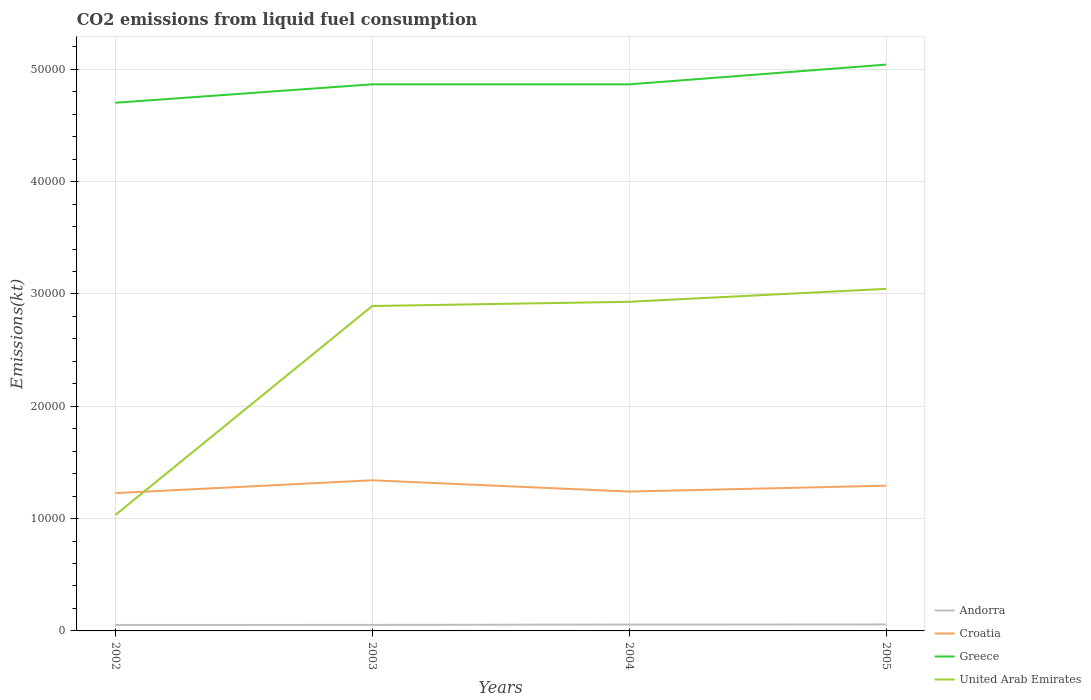Is the number of lines equal to the number of legend labels?
Keep it short and to the point. Yes. Across all years, what is the maximum amount of CO2 emitted in Croatia?
Ensure brevity in your answer.  1.23e+04. In which year was the amount of CO2 emitted in Greece maximum?
Your answer should be compact. 2002. What is the total amount of CO2 emitted in Greece in the graph?
Offer a very short reply. 3.67. What is the difference between the highest and the second highest amount of CO2 emitted in Andorra?
Your answer should be compact. 44. What is the difference between the highest and the lowest amount of CO2 emitted in Andorra?
Your response must be concise. 2. How many years are there in the graph?
Offer a terse response. 4. Does the graph contain any zero values?
Offer a very short reply. No. Where does the legend appear in the graph?
Your response must be concise. Bottom right. How many legend labels are there?
Provide a succinct answer. 4. What is the title of the graph?
Offer a terse response. CO2 emissions from liquid fuel consumption. What is the label or title of the Y-axis?
Give a very brief answer. Emissions(kt). What is the Emissions(kt) in Andorra in 2002?
Your response must be concise. 531.72. What is the Emissions(kt) in Croatia in 2002?
Your response must be concise. 1.23e+04. What is the Emissions(kt) of Greece in 2002?
Provide a succinct answer. 4.70e+04. What is the Emissions(kt) in United Arab Emirates in 2002?
Make the answer very short. 1.03e+04. What is the Emissions(kt) of Andorra in 2003?
Give a very brief answer. 535.38. What is the Emissions(kt) in Croatia in 2003?
Provide a short and direct response. 1.34e+04. What is the Emissions(kt) of Greece in 2003?
Your response must be concise. 4.87e+04. What is the Emissions(kt) of United Arab Emirates in 2003?
Give a very brief answer. 2.89e+04. What is the Emissions(kt) in Andorra in 2004?
Give a very brief answer. 564.72. What is the Emissions(kt) in Croatia in 2004?
Ensure brevity in your answer.  1.24e+04. What is the Emissions(kt) of Greece in 2004?
Offer a very short reply. 4.87e+04. What is the Emissions(kt) of United Arab Emirates in 2004?
Keep it short and to the point. 2.93e+04. What is the Emissions(kt) in Andorra in 2005?
Give a very brief answer. 575.72. What is the Emissions(kt) of Croatia in 2005?
Your answer should be very brief. 1.29e+04. What is the Emissions(kt) of Greece in 2005?
Keep it short and to the point. 5.04e+04. What is the Emissions(kt) of United Arab Emirates in 2005?
Keep it short and to the point. 3.05e+04. Across all years, what is the maximum Emissions(kt) of Andorra?
Give a very brief answer. 575.72. Across all years, what is the maximum Emissions(kt) in Croatia?
Make the answer very short. 1.34e+04. Across all years, what is the maximum Emissions(kt) in Greece?
Your response must be concise. 5.04e+04. Across all years, what is the maximum Emissions(kt) of United Arab Emirates?
Offer a very short reply. 3.05e+04. Across all years, what is the minimum Emissions(kt) in Andorra?
Make the answer very short. 531.72. Across all years, what is the minimum Emissions(kt) of Croatia?
Keep it short and to the point. 1.23e+04. Across all years, what is the minimum Emissions(kt) of Greece?
Give a very brief answer. 4.70e+04. Across all years, what is the minimum Emissions(kt) in United Arab Emirates?
Ensure brevity in your answer.  1.03e+04. What is the total Emissions(kt) in Andorra in the graph?
Make the answer very short. 2207.53. What is the total Emissions(kt) in Croatia in the graph?
Your answer should be compact. 5.10e+04. What is the total Emissions(kt) of Greece in the graph?
Offer a very short reply. 1.95e+05. What is the total Emissions(kt) in United Arab Emirates in the graph?
Offer a terse response. 9.90e+04. What is the difference between the Emissions(kt) of Andorra in 2002 and that in 2003?
Offer a terse response. -3.67. What is the difference between the Emissions(kt) of Croatia in 2002 and that in 2003?
Your answer should be compact. -1140.44. What is the difference between the Emissions(kt) of Greece in 2002 and that in 2003?
Keep it short and to the point. -1642.82. What is the difference between the Emissions(kt) in United Arab Emirates in 2002 and that in 2003?
Give a very brief answer. -1.86e+04. What is the difference between the Emissions(kt) in Andorra in 2002 and that in 2004?
Keep it short and to the point. -33. What is the difference between the Emissions(kt) of Croatia in 2002 and that in 2004?
Your answer should be very brief. -139.35. What is the difference between the Emissions(kt) in Greece in 2002 and that in 2004?
Your response must be concise. -1639.15. What is the difference between the Emissions(kt) of United Arab Emirates in 2002 and that in 2004?
Your response must be concise. -1.90e+04. What is the difference between the Emissions(kt) of Andorra in 2002 and that in 2005?
Make the answer very short. -44. What is the difference between the Emissions(kt) in Croatia in 2002 and that in 2005?
Ensure brevity in your answer.  -660.06. What is the difference between the Emissions(kt) in Greece in 2002 and that in 2005?
Provide a short and direct response. -3399.31. What is the difference between the Emissions(kt) of United Arab Emirates in 2002 and that in 2005?
Provide a succinct answer. -2.01e+04. What is the difference between the Emissions(kt) of Andorra in 2003 and that in 2004?
Keep it short and to the point. -29.34. What is the difference between the Emissions(kt) in Croatia in 2003 and that in 2004?
Make the answer very short. 1001.09. What is the difference between the Emissions(kt) of Greece in 2003 and that in 2004?
Your answer should be compact. 3.67. What is the difference between the Emissions(kt) in United Arab Emirates in 2003 and that in 2004?
Ensure brevity in your answer.  -374.03. What is the difference between the Emissions(kt) of Andorra in 2003 and that in 2005?
Offer a terse response. -40.34. What is the difference between the Emissions(kt) of Croatia in 2003 and that in 2005?
Your response must be concise. 480.38. What is the difference between the Emissions(kt) in Greece in 2003 and that in 2005?
Provide a succinct answer. -1756.49. What is the difference between the Emissions(kt) in United Arab Emirates in 2003 and that in 2005?
Offer a terse response. -1525.47. What is the difference between the Emissions(kt) in Andorra in 2004 and that in 2005?
Your answer should be compact. -11. What is the difference between the Emissions(kt) of Croatia in 2004 and that in 2005?
Offer a very short reply. -520.71. What is the difference between the Emissions(kt) in Greece in 2004 and that in 2005?
Ensure brevity in your answer.  -1760.16. What is the difference between the Emissions(kt) of United Arab Emirates in 2004 and that in 2005?
Keep it short and to the point. -1151.44. What is the difference between the Emissions(kt) of Andorra in 2002 and the Emissions(kt) of Croatia in 2003?
Give a very brief answer. -1.29e+04. What is the difference between the Emissions(kt) of Andorra in 2002 and the Emissions(kt) of Greece in 2003?
Provide a succinct answer. -4.81e+04. What is the difference between the Emissions(kt) in Andorra in 2002 and the Emissions(kt) in United Arab Emirates in 2003?
Your answer should be compact. -2.84e+04. What is the difference between the Emissions(kt) of Croatia in 2002 and the Emissions(kt) of Greece in 2003?
Make the answer very short. -3.64e+04. What is the difference between the Emissions(kt) of Croatia in 2002 and the Emissions(kt) of United Arab Emirates in 2003?
Offer a very short reply. -1.67e+04. What is the difference between the Emissions(kt) of Greece in 2002 and the Emissions(kt) of United Arab Emirates in 2003?
Make the answer very short. 1.81e+04. What is the difference between the Emissions(kt) of Andorra in 2002 and the Emissions(kt) of Croatia in 2004?
Provide a short and direct response. -1.19e+04. What is the difference between the Emissions(kt) of Andorra in 2002 and the Emissions(kt) of Greece in 2004?
Provide a short and direct response. -4.81e+04. What is the difference between the Emissions(kt) in Andorra in 2002 and the Emissions(kt) in United Arab Emirates in 2004?
Your answer should be compact. -2.88e+04. What is the difference between the Emissions(kt) in Croatia in 2002 and the Emissions(kt) in Greece in 2004?
Make the answer very short. -3.64e+04. What is the difference between the Emissions(kt) of Croatia in 2002 and the Emissions(kt) of United Arab Emirates in 2004?
Offer a terse response. -1.70e+04. What is the difference between the Emissions(kt) in Greece in 2002 and the Emissions(kt) in United Arab Emirates in 2004?
Keep it short and to the point. 1.77e+04. What is the difference between the Emissions(kt) of Andorra in 2002 and the Emissions(kt) of Croatia in 2005?
Make the answer very short. -1.24e+04. What is the difference between the Emissions(kt) of Andorra in 2002 and the Emissions(kt) of Greece in 2005?
Provide a succinct answer. -4.99e+04. What is the difference between the Emissions(kt) in Andorra in 2002 and the Emissions(kt) in United Arab Emirates in 2005?
Make the answer very short. -2.99e+04. What is the difference between the Emissions(kt) in Croatia in 2002 and the Emissions(kt) in Greece in 2005?
Your answer should be very brief. -3.82e+04. What is the difference between the Emissions(kt) of Croatia in 2002 and the Emissions(kt) of United Arab Emirates in 2005?
Offer a very short reply. -1.82e+04. What is the difference between the Emissions(kt) of Greece in 2002 and the Emissions(kt) of United Arab Emirates in 2005?
Give a very brief answer. 1.66e+04. What is the difference between the Emissions(kt) in Andorra in 2003 and the Emissions(kt) in Croatia in 2004?
Offer a terse response. -1.19e+04. What is the difference between the Emissions(kt) in Andorra in 2003 and the Emissions(kt) in Greece in 2004?
Provide a succinct answer. -4.81e+04. What is the difference between the Emissions(kt) of Andorra in 2003 and the Emissions(kt) of United Arab Emirates in 2004?
Your answer should be very brief. -2.88e+04. What is the difference between the Emissions(kt) of Croatia in 2003 and the Emissions(kt) of Greece in 2004?
Offer a terse response. -3.53e+04. What is the difference between the Emissions(kt) in Croatia in 2003 and the Emissions(kt) in United Arab Emirates in 2004?
Make the answer very short. -1.59e+04. What is the difference between the Emissions(kt) of Greece in 2003 and the Emissions(kt) of United Arab Emirates in 2004?
Offer a very short reply. 1.94e+04. What is the difference between the Emissions(kt) of Andorra in 2003 and the Emissions(kt) of Croatia in 2005?
Keep it short and to the point. -1.24e+04. What is the difference between the Emissions(kt) of Andorra in 2003 and the Emissions(kt) of Greece in 2005?
Keep it short and to the point. -4.99e+04. What is the difference between the Emissions(kt) in Andorra in 2003 and the Emissions(kt) in United Arab Emirates in 2005?
Your response must be concise. -2.99e+04. What is the difference between the Emissions(kt) of Croatia in 2003 and the Emissions(kt) of Greece in 2005?
Your answer should be compact. -3.70e+04. What is the difference between the Emissions(kt) of Croatia in 2003 and the Emissions(kt) of United Arab Emirates in 2005?
Your response must be concise. -1.70e+04. What is the difference between the Emissions(kt) of Greece in 2003 and the Emissions(kt) of United Arab Emirates in 2005?
Your response must be concise. 1.82e+04. What is the difference between the Emissions(kt) in Andorra in 2004 and the Emissions(kt) in Croatia in 2005?
Provide a succinct answer. -1.24e+04. What is the difference between the Emissions(kt) in Andorra in 2004 and the Emissions(kt) in Greece in 2005?
Offer a very short reply. -4.99e+04. What is the difference between the Emissions(kt) of Andorra in 2004 and the Emissions(kt) of United Arab Emirates in 2005?
Provide a succinct answer. -2.99e+04. What is the difference between the Emissions(kt) in Croatia in 2004 and the Emissions(kt) in Greece in 2005?
Offer a terse response. -3.80e+04. What is the difference between the Emissions(kt) in Croatia in 2004 and the Emissions(kt) in United Arab Emirates in 2005?
Make the answer very short. -1.80e+04. What is the difference between the Emissions(kt) in Greece in 2004 and the Emissions(kt) in United Arab Emirates in 2005?
Keep it short and to the point. 1.82e+04. What is the average Emissions(kt) of Andorra per year?
Provide a succinct answer. 551.88. What is the average Emissions(kt) of Croatia per year?
Ensure brevity in your answer.  1.28e+04. What is the average Emissions(kt) of Greece per year?
Ensure brevity in your answer.  4.87e+04. What is the average Emissions(kt) of United Arab Emirates per year?
Offer a very short reply. 2.48e+04. In the year 2002, what is the difference between the Emissions(kt) of Andorra and Emissions(kt) of Croatia?
Make the answer very short. -1.17e+04. In the year 2002, what is the difference between the Emissions(kt) in Andorra and Emissions(kt) in Greece?
Keep it short and to the point. -4.65e+04. In the year 2002, what is the difference between the Emissions(kt) in Andorra and Emissions(kt) in United Arab Emirates?
Ensure brevity in your answer.  -9787.22. In the year 2002, what is the difference between the Emissions(kt) of Croatia and Emissions(kt) of Greece?
Offer a very short reply. -3.48e+04. In the year 2002, what is the difference between the Emissions(kt) of Croatia and Emissions(kt) of United Arab Emirates?
Offer a very short reply. 1950.84. In the year 2002, what is the difference between the Emissions(kt) in Greece and Emissions(kt) in United Arab Emirates?
Keep it short and to the point. 3.67e+04. In the year 2003, what is the difference between the Emissions(kt) in Andorra and Emissions(kt) in Croatia?
Your answer should be compact. -1.29e+04. In the year 2003, what is the difference between the Emissions(kt) of Andorra and Emissions(kt) of Greece?
Offer a very short reply. -4.81e+04. In the year 2003, what is the difference between the Emissions(kt) in Andorra and Emissions(kt) in United Arab Emirates?
Keep it short and to the point. -2.84e+04. In the year 2003, what is the difference between the Emissions(kt) in Croatia and Emissions(kt) in Greece?
Your answer should be very brief. -3.53e+04. In the year 2003, what is the difference between the Emissions(kt) in Croatia and Emissions(kt) in United Arab Emirates?
Make the answer very short. -1.55e+04. In the year 2003, what is the difference between the Emissions(kt) in Greece and Emissions(kt) in United Arab Emirates?
Give a very brief answer. 1.97e+04. In the year 2004, what is the difference between the Emissions(kt) in Andorra and Emissions(kt) in Croatia?
Your answer should be compact. -1.18e+04. In the year 2004, what is the difference between the Emissions(kt) in Andorra and Emissions(kt) in Greece?
Keep it short and to the point. -4.81e+04. In the year 2004, what is the difference between the Emissions(kt) in Andorra and Emissions(kt) in United Arab Emirates?
Offer a very short reply. -2.87e+04. In the year 2004, what is the difference between the Emissions(kt) in Croatia and Emissions(kt) in Greece?
Your response must be concise. -3.63e+04. In the year 2004, what is the difference between the Emissions(kt) in Croatia and Emissions(kt) in United Arab Emirates?
Offer a terse response. -1.69e+04. In the year 2004, what is the difference between the Emissions(kt) in Greece and Emissions(kt) in United Arab Emirates?
Give a very brief answer. 1.94e+04. In the year 2005, what is the difference between the Emissions(kt) of Andorra and Emissions(kt) of Croatia?
Give a very brief answer. -1.24e+04. In the year 2005, what is the difference between the Emissions(kt) of Andorra and Emissions(kt) of Greece?
Provide a short and direct response. -4.98e+04. In the year 2005, what is the difference between the Emissions(kt) of Andorra and Emissions(kt) of United Arab Emirates?
Your answer should be very brief. -2.99e+04. In the year 2005, what is the difference between the Emissions(kt) of Croatia and Emissions(kt) of Greece?
Provide a succinct answer. -3.75e+04. In the year 2005, what is the difference between the Emissions(kt) of Croatia and Emissions(kt) of United Arab Emirates?
Give a very brief answer. -1.75e+04. In the year 2005, what is the difference between the Emissions(kt) of Greece and Emissions(kt) of United Arab Emirates?
Provide a succinct answer. 2.00e+04. What is the ratio of the Emissions(kt) in Andorra in 2002 to that in 2003?
Ensure brevity in your answer.  0.99. What is the ratio of the Emissions(kt) in Croatia in 2002 to that in 2003?
Your response must be concise. 0.92. What is the ratio of the Emissions(kt) of Greece in 2002 to that in 2003?
Give a very brief answer. 0.97. What is the ratio of the Emissions(kt) in United Arab Emirates in 2002 to that in 2003?
Offer a terse response. 0.36. What is the ratio of the Emissions(kt) in Andorra in 2002 to that in 2004?
Your response must be concise. 0.94. What is the ratio of the Emissions(kt) of Croatia in 2002 to that in 2004?
Make the answer very short. 0.99. What is the ratio of the Emissions(kt) in Greece in 2002 to that in 2004?
Your response must be concise. 0.97. What is the ratio of the Emissions(kt) of United Arab Emirates in 2002 to that in 2004?
Keep it short and to the point. 0.35. What is the ratio of the Emissions(kt) of Andorra in 2002 to that in 2005?
Give a very brief answer. 0.92. What is the ratio of the Emissions(kt) of Croatia in 2002 to that in 2005?
Your answer should be compact. 0.95. What is the ratio of the Emissions(kt) in Greece in 2002 to that in 2005?
Your answer should be compact. 0.93. What is the ratio of the Emissions(kt) of United Arab Emirates in 2002 to that in 2005?
Keep it short and to the point. 0.34. What is the ratio of the Emissions(kt) in Andorra in 2003 to that in 2004?
Offer a very short reply. 0.95. What is the ratio of the Emissions(kt) of Croatia in 2003 to that in 2004?
Make the answer very short. 1.08. What is the ratio of the Emissions(kt) of Greece in 2003 to that in 2004?
Your answer should be very brief. 1. What is the ratio of the Emissions(kt) of United Arab Emirates in 2003 to that in 2004?
Provide a short and direct response. 0.99. What is the ratio of the Emissions(kt) in Andorra in 2003 to that in 2005?
Provide a short and direct response. 0.93. What is the ratio of the Emissions(kt) in Croatia in 2003 to that in 2005?
Your answer should be very brief. 1.04. What is the ratio of the Emissions(kt) in Greece in 2003 to that in 2005?
Provide a short and direct response. 0.97. What is the ratio of the Emissions(kt) in United Arab Emirates in 2003 to that in 2005?
Provide a succinct answer. 0.95. What is the ratio of the Emissions(kt) in Andorra in 2004 to that in 2005?
Provide a succinct answer. 0.98. What is the ratio of the Emissions(kt) in Croatia in 2004 to that in 2005?
Provide a succinct answer. 0.96. What is the ratio of the Emissions(kt) in Greece in 2004 to that in 2005?
Provide a succinct answer. 0.97. What is the ratio of the Emissions(kt) of United Arab Emirates in 2004 to that in 2005?
Provide a succinct answer. 0.96. What is the difference between the highest and the second highest Emissions(kt) of Andorra?
Your answer should be very brief. 11. What is the difference between the highest and the second highest Emissions(kt) of Croatia?
Make the answer very short. 480.38. What is the difference between the highest and the second highest Emissions(kt) in Greece?
Provide a short and direct response. 1756.49. What is the difference between the highest and the second highest Emissions(kt) of United Arab Emirates?
Provide a succinct answer. 1151.44. What is the difference between the highest and the lowest Emissions(kt) of Andorra?
Offer a terse response. 44. What is the difference between the highest and the lowest Emissions(kt) of Croatia?
Your answer should be compact. 1140.44. What is the difference between the highest and the lowest Emissions(kt) of Greece?
Provide a succinct answer. 3399.31. What is the difference between the highest and the lowest Emissions(kt) in United Arab Emirates?
Ensure brevity in your answer.  2.01e+04. 